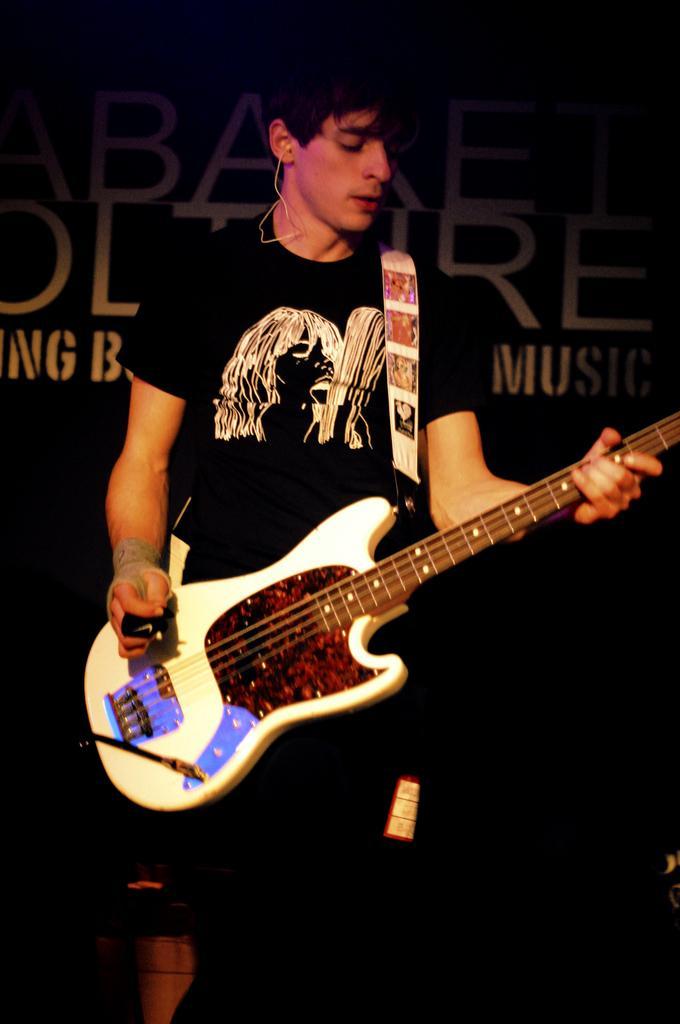Please provide a concise description of this image. The picture is from the musical concert where a black shirt guy is playing a guitar. The guitar is white in color. In the background there is a black poster which is named as MUSIC. 